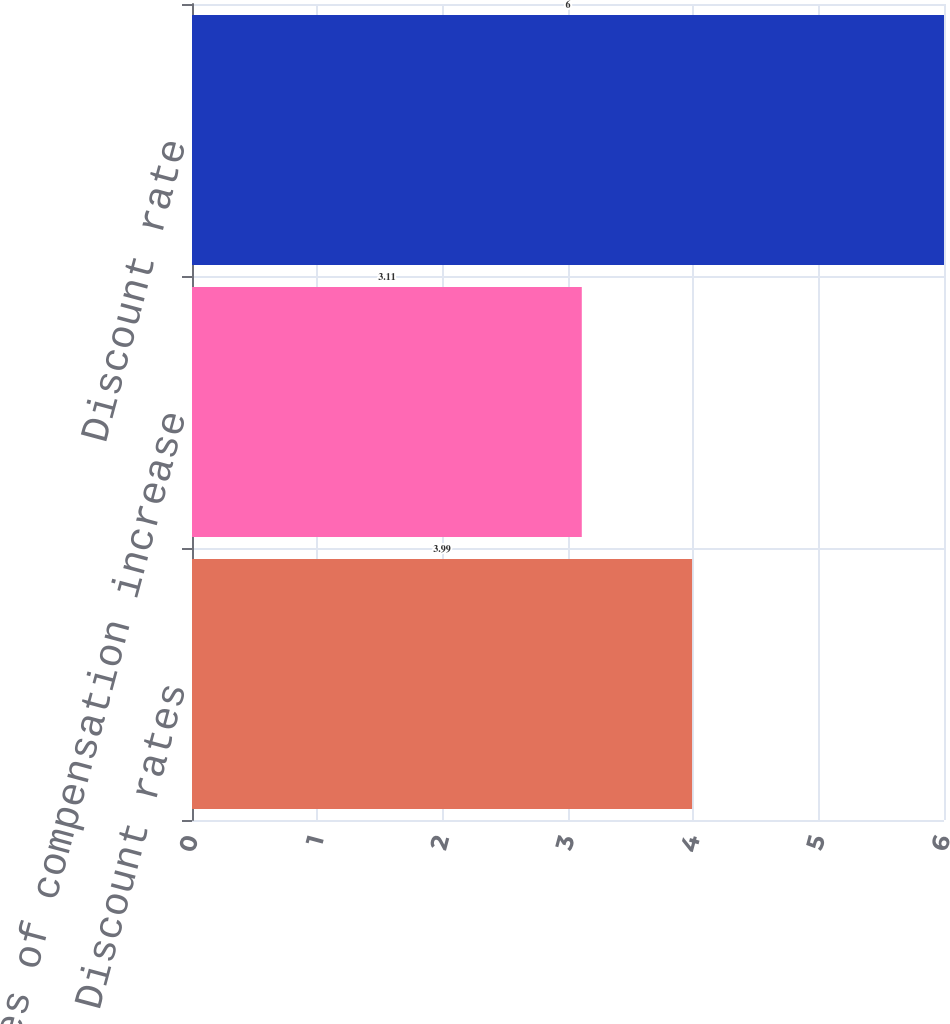Convert chart to OTSL. <chart><loc_0><loc_0><loc_500><loc_500><bar_chart><fcel>Discount rates<fcel>Rates of compensation increase<fcel>Discount rate<nl><fcel>3.99<fcel>3.11<fcel>6<nl></chart> 